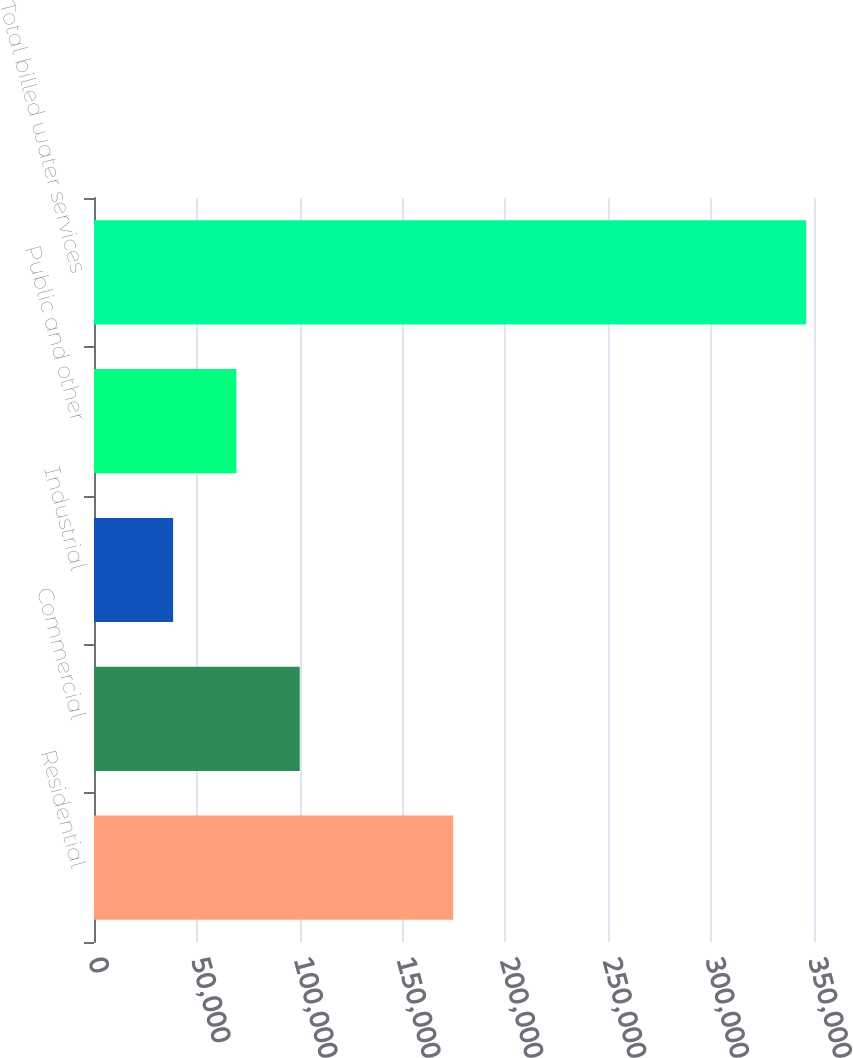<chart> <loc_0><loc_0><loc_500><loc_500><bar_chart><fcel>Residential<fcel>Commercial<fcel>Industrial<fcel>Public and other<fcel>Total billed water services<nl><fcel>174599<fcel>100018<fcel>38465<fcel>69241.6<fcel>346231<nl></chart> 